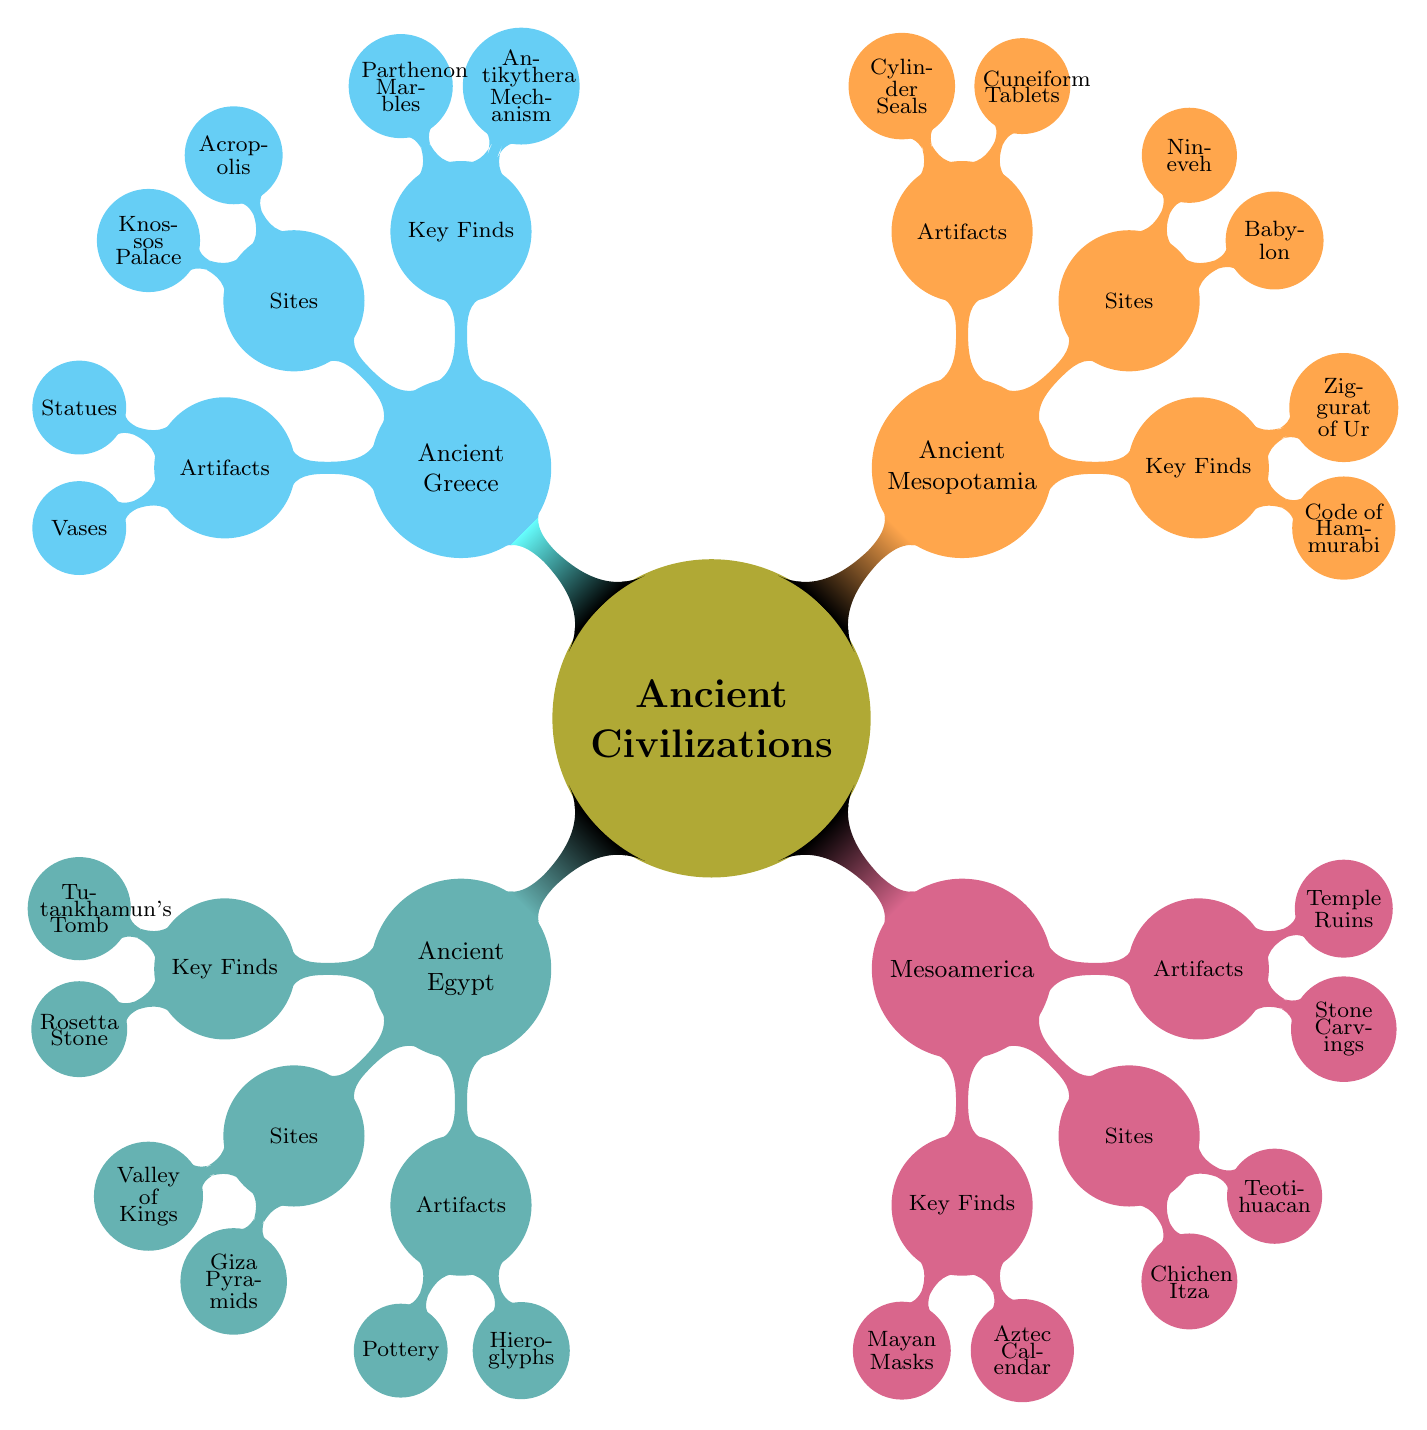What are the two key finds for Ancient Greece? The mind map shows a branch for Ancient Greece which lists its key finds as "Antikythera Mechanism" and "Parthenon Marbles."
Answer: Antikythera Mechanism, Parthenon Marbles How many significant sites are listed for Mesoamerica? In the Mesoamerica branch of the mind map, there are two child nodes under the "Sites" category: "Chichen Itza" and "Teotihuacan." Counting these gives us 2 significant sites.
Answer: 2 What type of artifacts were found in Ancient Mesopotamia? The mind map illustrates a branch for Ancient Mesopotamia where "Artifact Types" includes "Cuneiform Tablets" and "Cylinder Seals." These are the types listed, showing what artifacts were found.
Answer: Cuneiform Tablets, Cylinder Seals Which civilization has the largest number of key finds listed? By comparing the key finds listed under each civilization, Ancient Egypt, Ancient Greece, Mesoamerica, and Ancient Mesopotamia all have two finds. Therefore, they have the same number; no civilization has a larger count.
Answer: Ancient Egypt, Ancient Greece, Mesoamerica, Ancient Mesopotamia In which significant site can you find the Giza Pyramids? The mind map specifies Giza Pyramids as one of the significant sites listed under Ancient Egypt. This is a direct association from the diagram showing its location in the corresponding section.
Answer: Ancient Egypt 